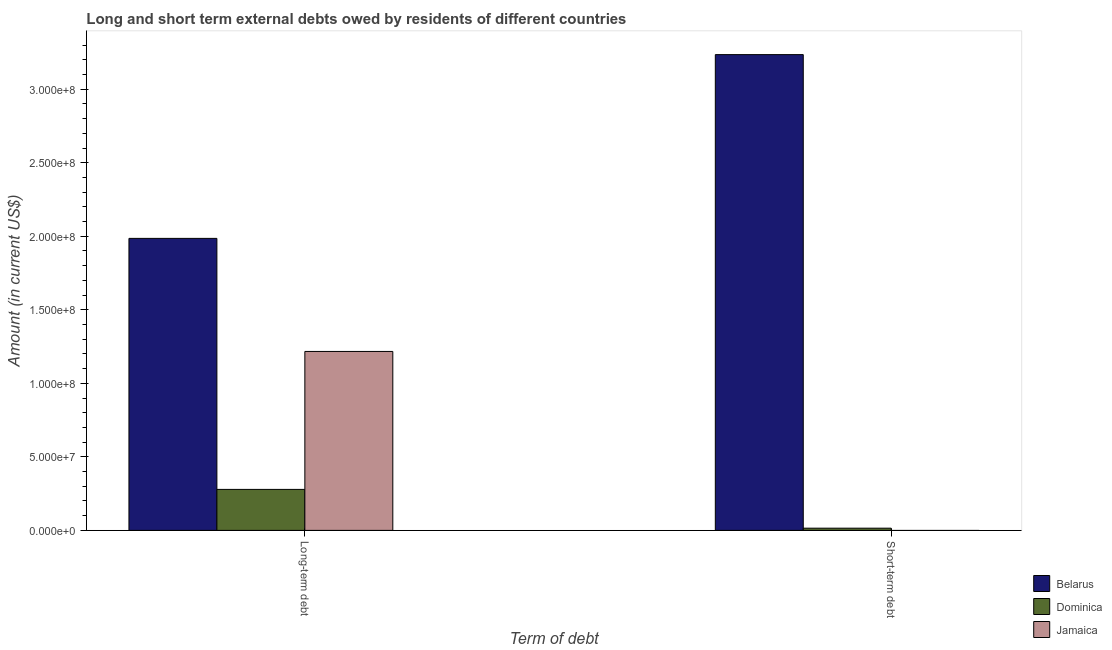How many different coloured bars are there?
Give a very brief answer. 3. How many bars are there on the 2nd tick from the left?
Make the answer very short. 2. How many bars are there on the 1st tick from the right?
Offer a very short reply. 2. What is the label of the 1st group of bars from the left?
Your answer should be very brief. Long-term debt. What is the long-term debts owed by residents in Jamaica?
Offer a terse response. 1.22e+08. Across all countries, what is the maximum short-term debts owed by residents?
Offer a very short reply. 3.24e+08. Across all countries, what is the minimum short-term debts owed by residents?
Your response must be concise. 0. In which country was the short-term debts owed by residents maximum?
Make the answer very short. Belarus. What is the total long-term debts owed by residents in the graph?
Your answer should be compact. 3.48e+08. What is the difference between the short-term debts owed by residents in Dominica and that in Belarus?
Ensure brevity in your answer.  -3.22e+08. What is the difference between the short-term debts owed by residents in Dominica and the long-term debts owed by residents in Jamaica?
Keep it short and to the point. -1.20e+08. What is the average long-term debts owed by residents per country?
Your response must be concise. 1.16e+08. What is the difference between the long-term debts owed by residents and short-term debts owed by residents in Dominica?
Make the answer very short. 2.64e+07. In how many countries, is the long-term debts owed by residents greater than 310000000 US$?
Ensure brevity in your answer.  0. What is the ratio of the long-term debts owed by residents in Jamaica to that in Belarus?
Your answer should be compact. 0.61. In how many countries, is the long-term debts owed by residents greater than the average long-term debts owed by residents taken over all countries?
Provide a succinct answer. 2. How many countries are there in the graph?
Make the answer very short. 3. How are the legend labels stacked?
Offer a very short reply. Vertical. What is the title of the graph?
Your response must be concise. Long and short term external debts owed by residents of different countries. Does "Egypt, Arab Rep." appear as one of the legend labels in the graph?
Your answer should be very brief. No. What is the label or title of the X-axis?
Provide a succinct answer. Term of debt. What is the Amount (in current US$) of Belarus in Long-term debt?
Provide a succinct answer. 1.99e+08. What is the Amount (in current US$) in Dominica in Long-term debt?
Your response must be concise. 2.79e+07. What is the Amount (in current US$) of Jamaica in Long-term debt?
Offer a terse response. 1.22e+08. What is the Amount (in current US$) of Belarus in Short-term debt?
Make the answer very short. 3.24e+08. What is the Amount (in current US$) in Dominica in Short-term debt?
Your answer should be compact. 1.50e+06. What is the Amount (in current US$) in Jamaica in Short-term debt?
Give a very brief answer. 0. Across all Term of debt, what is the maximum Amount (in current US$) of Belarus?
Provide a short and direct response. 3.24e+08. Across all Term of debt, what is the maximum Amount (in current US$) of Dominica?
Your answer should be compact. 2.79e+07. Across all Term of debt, what is the maximum Amount (in current US$) of Jamaica?
Keep it short and to the point. 1.22e+08. Across all Term of debt, what is the minimum Amount (in current US$) in Belarus?
Offer a terse response. 1.99e+08. Across all Term of debt, what is the minimum Amount (in current US$) in Dominica?
Offer a very short reply. 1.50e+06. Across all Term of debt, what is the minimum Amount (in current US$) of Jamaica?
Your answer should be very brief. 0. What is the total Amount (in current US$) in Belarus in the graph?
Your answer should be very brief. 5.22e+08. What is the total Amount (in current US$) in Dominica in the graph?
Provide a short and direct response. 2.94e+07. What is the total Amount (in current US$) in Jamaica in the graph?
Provide a short and direct response. 1.22e+08. What is the difference between the Amount (in current US$) in Belarus in Long-term debt and that in Short-term debt?
Provide a succinct answer. -1.25e+08. What is the difference between the Amount (in current US$) in Dominica in Long-term debt and that in Short-term debt?
Provide a short and direct response. 2.64e+07. What is the difference between the Amount (in current US$) of Belarus in Long-term debt and the Amount (in current US$) of Dominica in Short-term debt?
Keep it short and to the point. 1.97e+08. What is the average Amount (in current US$) in Belarus per Term of debt?
Offer a very short reply. 2.61e+08. What is the average Amount (in current US$) of Dominica per Term of debt?
Give a very brief answer. 1.47e+07. What is the average Amount (in current US$) of Jamaica per Term of debt?
Your answer should be very brief. 6.08e+07. What is the difference between the Amount (in current US$) of Belarus and Amount (in current US$) of Dominica in Long-term debt?
Offer a very short reply. 1.71e+08. What is the difference between the Amount (in current US$) in Belarus and Amount (in current US$) in Jamaica in Long-term debt?
Your answer should be compact. 7.69e+07. What is the difference between the Amount (in current US$) in Dominica and Amount (in current US$) in Jamaica in Long-term debt?
Your response must be concise. -9.38e+07. What is the difference between the Amount (in current US$) in Belarus and Amount (in current US$) in Dominica in Short-term debt?
Offer a terse response. 3.22e+08. What is the ratio of the Amount (in current US$) in Belarus in Long-term debt to that in Short-term debt?
Provide a succinct answer. 0.61. What is the ratio of the Amount (in current US$) in Dominica in Long-term debt to that in Short-term debt?
Your answer should be compact. 18.58. What is the difference between the highest and the second highest Amount (in current US$) of Belarus?
Provide a succinct answer. 1.25e+08. What is the difference between the highest and the second highest Amount (in current US$) of Dominica?
Give a very brief answer. 2.64e+07. What is the difference between the highest and the lowest Amount (in current US$) of Belarus?
Offer a very short reply. 1.25e+08. What is the difference between the highest and the lowest Amount (in current US$) of Dominica?
Offer a terse response. 2.64e+07. What is the difference between the highest and the lowest Amount (in current US$) of Jamaica?
Keep it short and to the point. 1.22e+08. 